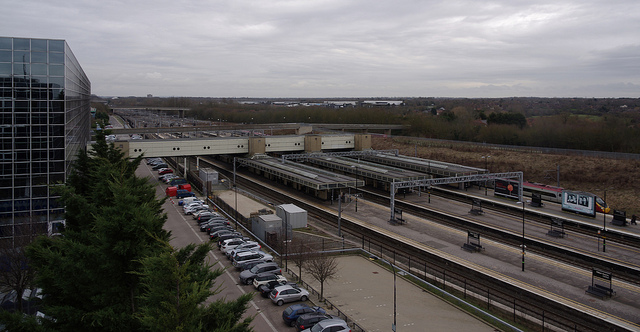<image>What color is the vehicle that is on the left side of the truck? I am not sure about the color of the vehicle on the left side of the truck. It could be red, white, tan or black. What color is the vehicle that is on the left side of the truck? I don't know what color the vehicle on the left side of the truck is. It can be either red, white, tan, or black. 